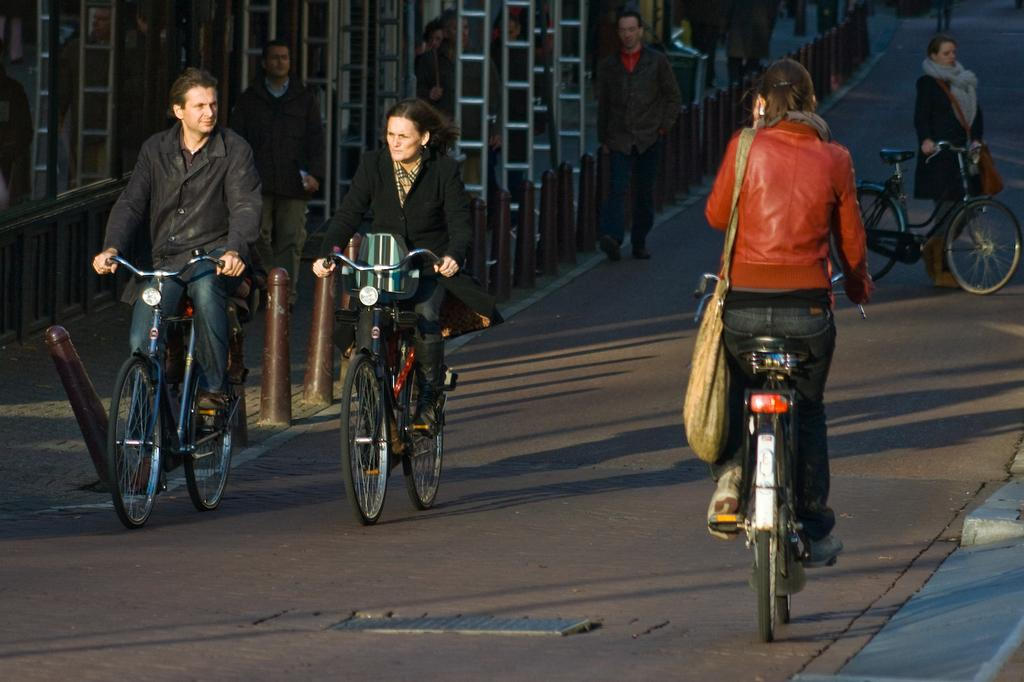What are the people in the image doing? The people in the image are riding bicycles. Where is the image taken? The image is taken on a road. What else can be seen in the image besides people riding bicycles? There are people walking on the pavement in the image. What color is the secretary's cast in the image? There is no secretary or cast present in the image. 